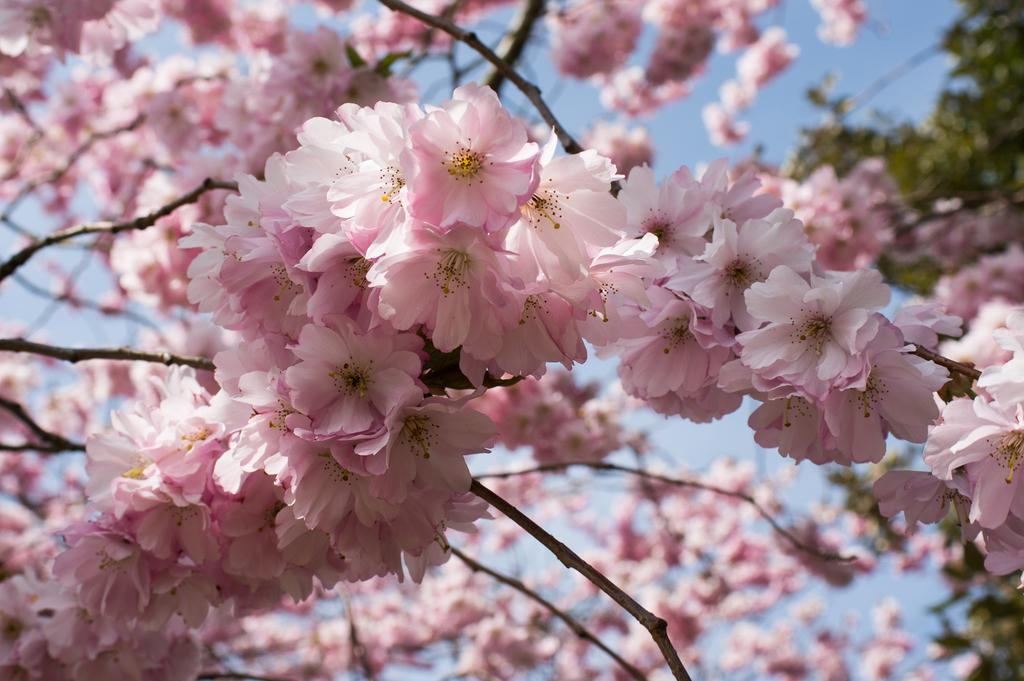Where was the image taken? The image is taken outdoors. What can be seen in the background of the image? There is a sky visible in the background. What type of plant is present in the image? There is a tree in the image. What is special about the tree in the image? The tree has many flowers. What color are the flowers on the tree? The flowers are pink in color. Can you see the mother of the flowers in the image? There is no mother figure present in the image; it features a tree with pink flowers. What type of shade does the tree provide in the image? The image does not show the tree providing shade, as it only shows the tree with flowers and no people or objects beneath it. 